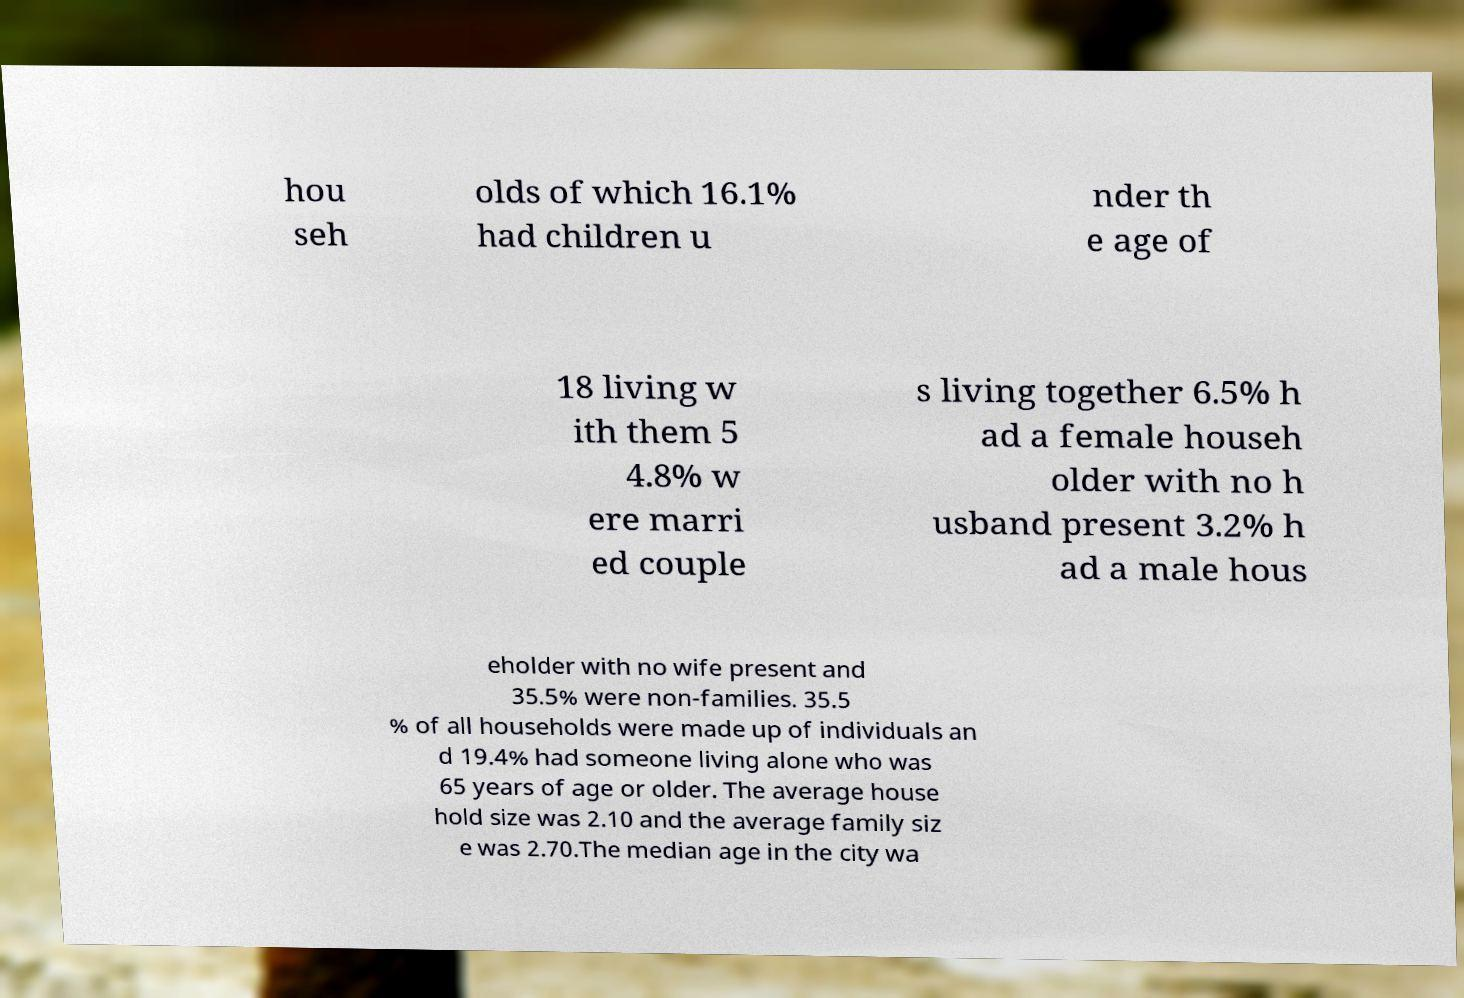Please identify and transcribe the text found in this image. hou seh olds of which 16.1% had children u nder th e age of 18 living w ith them 5 4.8% w ere marri ed couple s living together 6.5% h ad a female househ older with no h usband present 3.2% h ad a male hous eholder with no wife present and 35.5% were non-families. 35.5 % of all households were made up of individuals an d 19.4% had someone living alone who was 65 years of age or older. The average house hold size was 2.10 and the average family siz e was 2.70.The median age in the city wa 